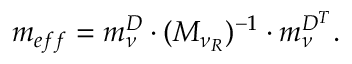<formula> <loc_0><loc_0><loc_500><loc_500>m _ { e f f } = m _ { \nu } ^ { D } \cdot ( M _ { \nu _ { R } } ) ^ { - 1 } \cdot m _ { \nu } ^ { D ^ { T } } .</formula> 